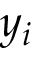Convert formula to latex. <formula><loc_0><loc_0><loc_500><loc_500>y _ { i }</formula> 